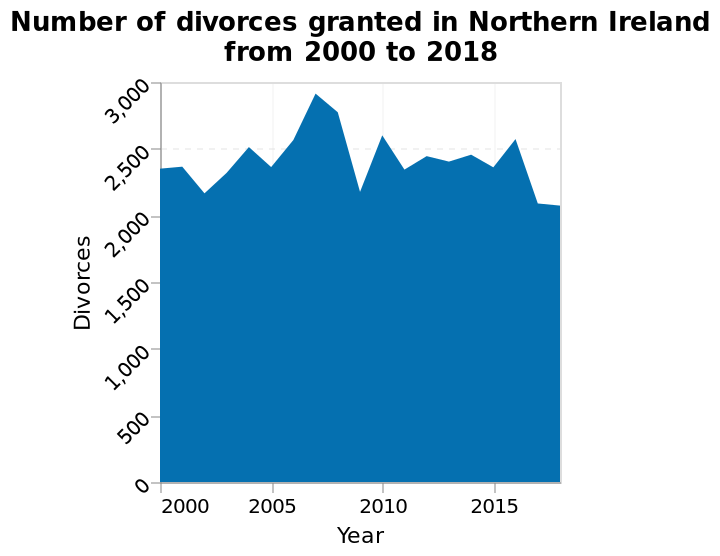<image>
What is the label on the x-axis of the area chart?  The label on the x-axis of the area chart is "Year". 